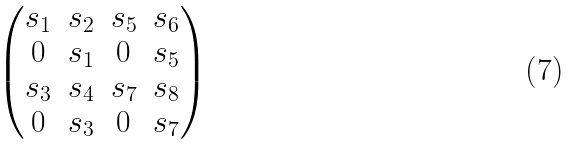<formula> <loc_0><loc_0><loc_500><loc_500>\begin{pmatrix} s _ { 1 } & s _ { 2 } & s _ { 5 } & s _ { 6 } \\ 0 & s _ { 1 } & 0 & s _ { 5 } \\ s _ { 3 } & s _ { 4 } & s _ { 7 } & s _ { 8 } \\ 0 & s _ { 3 } & 0 & s _ { 7 } \end{pmatrix}</formula> 